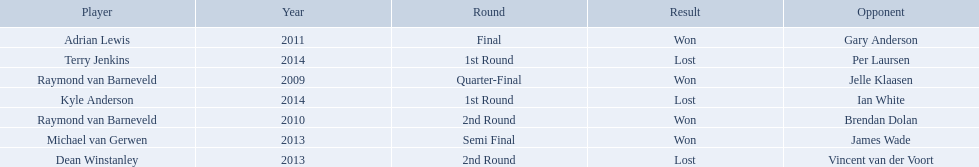Who are the players listed? Raymond van Barneveld, Raymond van Barneveld, Adrian Lewis, Dean Winstanley, Michael van Gerwen, Terry Jenkins, Kyle Anderson. Which of these players played in 2011? Adrian Lewis. 